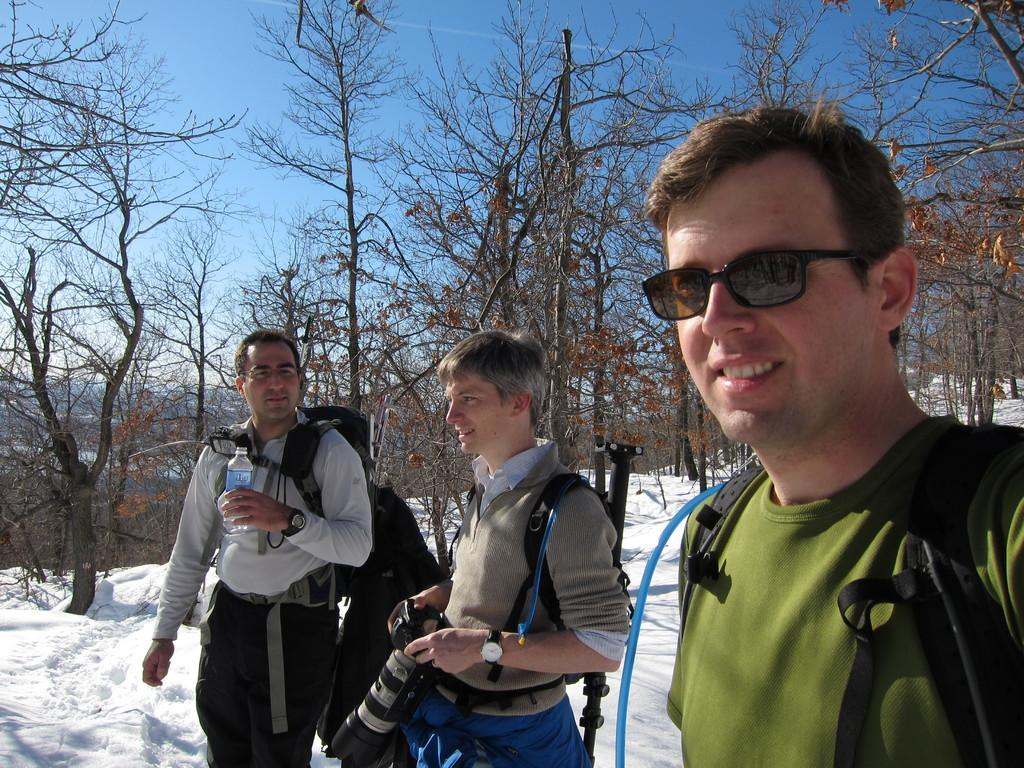Who or what can be seen in the image? There are people in the image. What is the surface the people are standing on? The people are standing on the snow. What can be seen in the distance behind the people? There are trees visible in the background of the image. What type of trade is being conducted in the image? There is no indication of any trade being conducted in the image; it simply shows people standing on snow with trees in the background. 